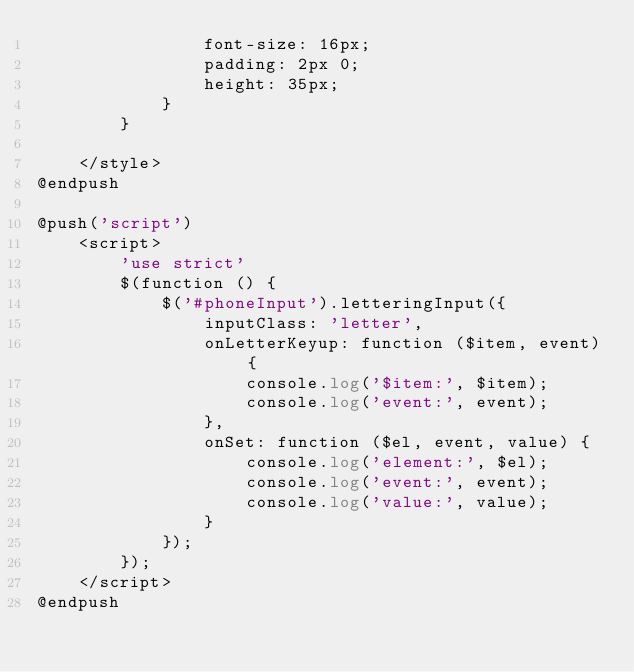<code> <loc_0><loc_0><loc_500><loc_500><_PHP_>                font-size: 16px;
                padding: 2px 0;
                height: 35px;
            }
        }

    </style>
@endpush

@push('script')
    <script>
        'use strict'
        $(function () {
            $('#phoneInput').letteringInput({
                inputClass: 'letter',
                onLetterKeyup: function ($item, event) {
                    console.log('$item:', $item);
                    console.log('event:', event);
                },
                onSet: function ($el, event, value) {
                    console.log('element:', $el);
                    console.log('event:', event);
                    console.log('value:', value);
                }
            });
        });
    </script>
@endpush
</code> 